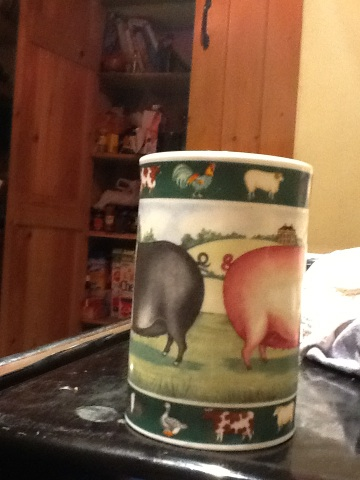Create a detailed scenario involving someone using this cup on a cozy winter morning. On a chilly winter morning, Emma wakes up to a blanket of snow outside her window. She wraps herself in a soft, warm robe and heads to the kitchen. She reaches for her favorite cup, the one adorned with charming farm animals. As she prepares her morning tea, the kettle whistles a harmonic tune. Emma pours the hot water over a fragrant blend of herbal tea, steam wafting up and filled with the scent of chamomile and lavender. She takes her cup back to her favorite armchair, beside a crackling fireplace. Wrapped in a cozy blanket, she cradles the cup in her hands, feeling the warmth seep through the porcelain. The intricate designs on the cup bring back fond memories of her childhood visits to her grandparents' farm. As she sips her tea, Emma looks out at the snow-covered landscape and feels a deep sense of peace and contentment, thankful for the small joys this cup brings into her life.  Describe a short realistic scenario involving this cup in a busy morning. On a hectic Monday morning, John grabs his farm-themed cup and pours himself a quick coffee. With meetings and deadlines looming, the cup is a small comfort amidst the whirlwind of activity. He sips his coffee while jotting down notes, appreciating the brief moment of calm before diving into the day’s chaos. 